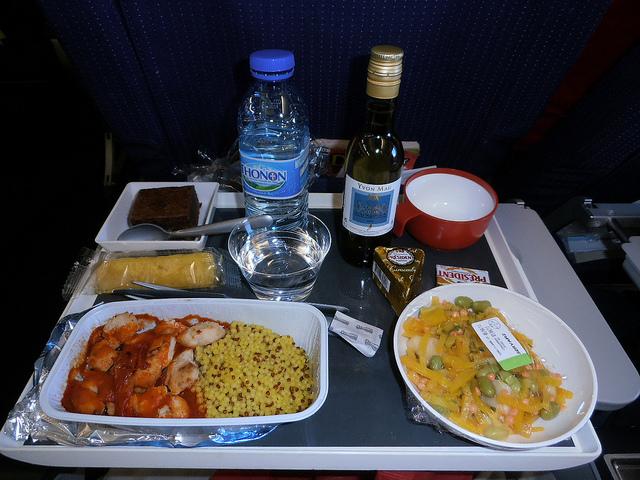What kind of drink is in the glass?
Be succinct. Water. Is there any cheese on the tray?
Be succinct. Yes. Is there ketchup?
Short answer required. No. Is this food partially eaten?
Give a very brief answer. No. Is this meal being served at a fine dining restaurant?
Keep it brief. No. What is mainly featured?
Give a very brief answer. Food. Is the water bottle open?
Answer briefly. Yes. 